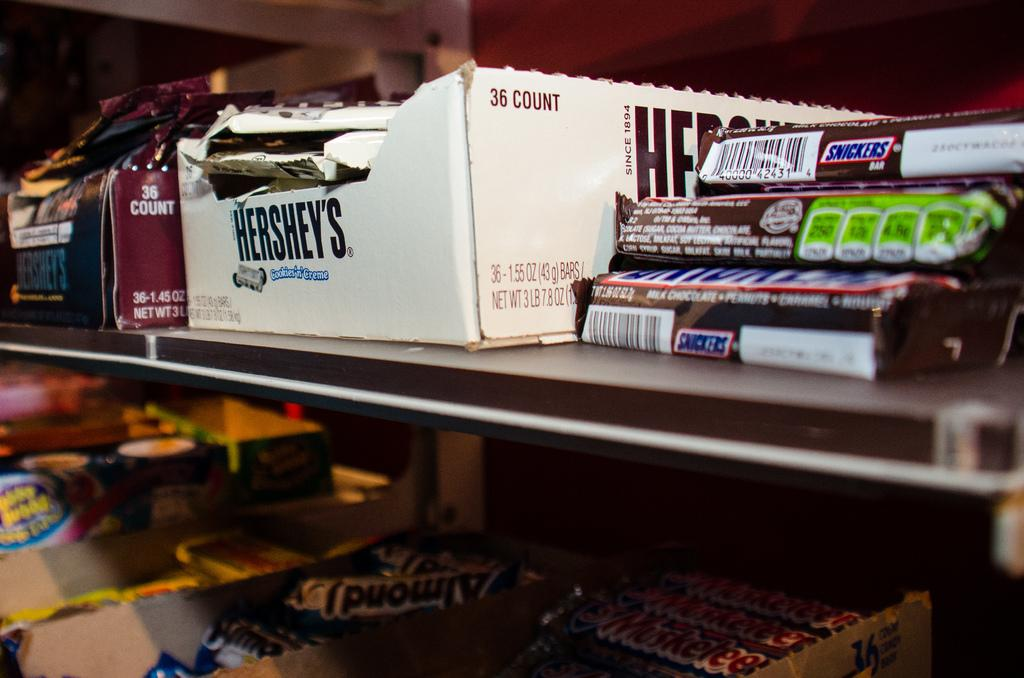<image>
Render a clear and concise summary of the photo. Snickers bars next to a box holding 36. 